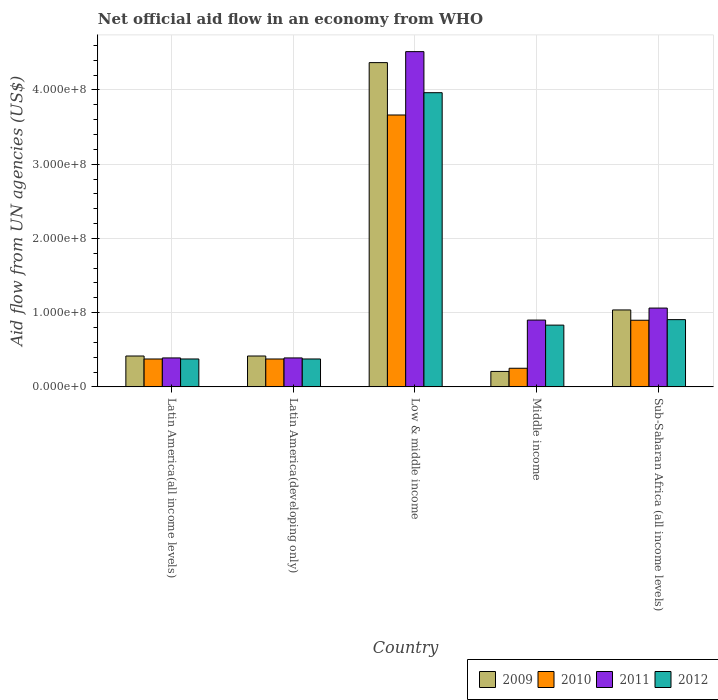How many different coloured bars are there?
Provide a short and direct response. 4. How many groups of bars are there?
Your answer should be compact. 5. Are the number of bars per tick equal to the number of legend labels?
Provide a short and direct response. Yes. What is the label of the 5th group of bars from the left?
Provide a succinct answer. Sub-Saharan Africa (all income levels). In how many cases, is the number of bars for a given country not equal to the number of legend labels?
Provide a succinct answer. 0. What is the net official aid flow in 2012 in Sub-Saharan Africa (all income levels)?
Your answer should be compact. 9.06e+07. Across all countries, what is the maximum net official aid flow in 2010?
Your answer should be very brief. 3.66e+08. Across all countries, what is the minimum net official aid flow in 2009?
Your response must be concise. 2.08e+07. In which country was the net official aid flow in 2011 minimum?
Offer a very short reply. Latin America(all income levels). What is the total net official aid flow in 2009 in the graph?
Provide a succinct answer. 6.44e+08. What is the difference between the net official aid flow in 2012 in Latin America(all income levels) and that in Sub-Saharan Africa (all income levels)?
Offer a very short reply. -5.30e+07. What is the difference between the net official aid flow in 2010 in Low & middle income and the net official aid flow in 2012 in Middle income?
Provide a short and direct response. 2.83e+08. What is the average net official aid flow in 2011 per country?
Give a very brief answer. 1.45e+08. What is the difference between the net official aid flow of/in 2012 and net official aid flow of/in 2010 in Low & middle income?
Provide a succinct answer. 3.00e+07. In how many countries, is the net official aid flow in 2010 greater than 360000000 US$?
Keep it short and to the point. 1. What is the ratio of the net official aid flow in 2012 in Low & middle income to that in Sub-Saharan Africa (all income levels)?
Your answer should be very brief. 4.38. Is the difference between the net official aid flow in 2012 in Latin America(all income levels) and Middle income greater than the difference between the net official aid flow in 2010 in Latin America(all income levels) and Middle income?
Your response must be concise. No. What is the difference between the highest and the second highest net official aid flow in 2011?
Make the answer very short. 3.45e+08. What is the difference between the highest and the lowest net official aid flow in 2011?
Your response must be concise. 4.13e+08. Is the sum of the net official aid flow in 2009 in Low & middle income and Middle income greater than the maximum net official aid flow in 2011 across all countries?
Keep it short and to the point. Yes. What does the 2nd bar from the left in Sub-Saharan Africa (all income levels) represents?
Offer a terse response. 2010. Are all the bars in the graph horizontal?
Your response must be concise. No. How many countries are there in the graph?
Offer a very short reply. 5. Are the values on the major ticks of Y-axis written in scientific E-notation?
Provide a succinct answer. Yes. Does the graph contain any zero values?
Keep it short and to the point. No. Where does the legend appear in the graph?
Your answer should be very brief. Bottom right. How many legend labels are there?
Your response must be concise. 4. What is the title of the graph?
Provide a short and direct response. Net official aid flow in an economy from WHO. Does "1961" appear as one of the legend labels in the graph?
Your answer should be compact. No. What is the label or title of the X-axis?
Provide a succinct answer. Country. What is the label or title of the Y-axis?
Your response must be concise. Aid flow from UN agencies (US$). What is the Aid flow from UN agencies (US$) of 2009 in Latin America(all income levels)?
Your answer should be very brief. 4.16e+07. What is the Aid flow from UN agencies (US$) in 2010 in Latin America(all income levels)?
Provide a succinct answer. 3.76e+07. What is the Aid flow from UN agencies (US$) of 2011 in Latin America(all income levels)?
Provide a short and direct response. 3.90e+07. What is the Aid flow from UN agencies (US$) of 2012 in Latin America(all income levels)?
Give a very brief answer. 3.76e+07. What is the Aid flow from UN agencies (US$) in 2009 in Latin America(developing only)?
Provide a short and direct response. 4.16e+07. What is the Aid flow from UN agencies (US$) of 2010 in Latin America(developing only)?
Ensure brevity in your answer.  3.76e+07. What is the Aid flow from UN agencies (US$) of 2011 in Latin America(developing only)?
Give a very brief answer. 3.90e+07. What is the Aid flow from UN agencies (US$) in 2012 in Latin America(developing only)?
Provide a succinct answer. 3.76e+07. What is the Aid flow from UN agencies (US$) of 2009 in Low & middle income?
Offer a very short reply. 4.37e+08. What is the Aid flow from UN agencies (US$) of 2010 in Low & middle income?
Offer a terse response. 3.66e+08. What is the Aid flow from UN agencies (US$) of 2011 in Low & middle income?
Your answer should be very brief. 4.52e+08. What is the Aid flow from UN agencies (US$) in 2012 in Low & middle income?
Your answer should be compact. 3.96e+08. What is the Aid flow from UN agencies (US$) of 2009 in Middle income?
Make the answer very short. 2.08e+07. What is the Aid flow from UN agencies (US$) in 2010 in Middle income?
Your answer should be very brief. 2.51e+07. What is the Aid flow from UN agencies (US$) in 2011 in Middle income?
Provide a succinct answer. 9.00e+07. What is the Aid flow from UN agencies (US$) in 2012 in Middle income?
Give a very brief answer. 8.32e+07. What is the Aid flow from UN agencies (US$) in 2009 in Sub-Saharan Africa (all income levels)?
Provide a short and direct response. 1.04e+08. What is the Aid flow from UN agencies (US$) of 2010 in Sub-Saharan Africa (all income levels)?
Make the answer very short. 8.98e+07. What is the Aid flow from UN agencies (US$) of 2011 in Sub-Saharan Africa (all income levels)?
Your answer should be very brief. 1.06e+08. What is the Aid flow from UN agencies (US$) of 2012 in Sub-Saharan Africa (all income levels)?
Offer a very short reply. 9.06e+07. Across all countries, what is the maximum Aid flow from UN agencies (US$) in 2009?
Ensure brevity in your answer.  4.37e+08. Across all countries, what is the maximum Aid flow from UN agencies (US$) in 2010?
Your answer should be very brief. 3.66e+08. Across all countries, what is the maximum Aid flow from UN agencies (US$) of 2011?
Provide a succinct answer. 4.52e+08. Across all countries, what is the maximum Aid flow from UN agencies (US$) in 2012?
Your answer should be compact. 3.96e+08. Across all countries, what is the minimum Aid flow from UN agencies (US$) in 2009?
Ensure brevity in your answer.  2.08e+07. Across all countries, what is the minimum Aid flow from UN agencies (US$) of 2010?
Your answer should be very brief. 2.51e+07. Across all countries, what is the minimum Aid flow from UN agencies (US$) in 2011?
Provide a succinct answer. 3.90e+07. Across all countries, what is the minimum Aid flow from UN agencies (US$) in 2012?
Keep it short and to the point. 3.76e+07. What is the total Aid flow from UN agencies (US$) of 2009 in the graph?
Keep it short and to the point. 6.44e+08. What is the total Aid flow from UN agencies (US$) in 2010 in the graph?
Your answer should be very brief. 5.56e+08. What is the total Aid flow from UN agencies (US$) in 2011 in the graph?
Make the answer very short. 7.26e+08. What is the total Aid flow from UN agencies (US$) of 2012 in the graph?
Offer a very short reply. 6.45e+08. What is the difference between the Aid flow from UN agencies (US$) of 2010 in Latin America(all income levels) and that in Latin America(developing only)?
Provide a short and direct response. 0. What is the difference between the Aid flow from UN agencies (US$) of 2009 in Latin America(all income levels) and that in Low & middle income?
Provide a succinct answer. -3.95e+08. What is the difference between the Aid flow from UN agencies (US$) of 2010 in Latin America(all income levels) and that in Low & middle income?
Provide a succinct answer. -3.29e+08. What is the difference between the Aid flow from UN agencies (US$) of 2011 in Latin America(all income levels) and that in Low & middle income?
Your answer should be compact. -4.13e+08. What is the difference between the Aid flow from UN agencies (US$) of 2012 in Latin America(all income levels) and that in Low & middle income?
Make the answer very short. -3.59e+08. What is the difference between the Aid flow from UN agencies (US$) in 2009 in Latin America(all income levels) and that in Middle income?
Offer a very short reply. 2.08e+07. What is the difference between the Aid flow from UN agencies (US$) in 2010 in Latin America(all income levels) and that in Middle income?
Your response must be concise. 1.25e+07. What is the difference between the Aid flow from UN agencies (US$) in 2011 in Latin America(all income levels) and that in Middle income?
Your answer should be compact. -5.10e+07. What is the difference between the Aid flow from UN agencies (US$) of 2012 in Latin America(all income levels) and that in Middle income?
Keep it short and to the point. -4.56e+07. What is the difference between the Aid flow from UN agencies (US$) in 2009 in Latin America(all income levels) and that in Sub-Saharan Africa (all income levels)?
Give a very brief answer. -6.20e+07. What is the difference between the Aid flow from UN agencies (US$) of 2010 in Latin America(all income levels) and that in Sub-Saharan Africa (all income levels)?
Make the answer very short. -5.22e+07. What is the difference between the Aid flow from UN agencies (US$) in 2011 in Latin America(all income levels) and that in Sub-Saharan Africa (all income levels)?
Ensure brevity in your answer.  -6.72e+07. What is the difference between the Aid flow from UN agencies (US$) of 2012 in Latin America(all income levels) and that in Sub-Saharan Africa (all income levels)?
Provide a short and direct response. -5.30e+07. What is the difference between the Aid flow from UN agencies (US$) of 2009 in Latin America(developing only) and that in Low & middle income?
Make the answer very short. -3.95e+08. What is the difference between the Aid flow from UN agencies (US$) in 2010 in Latin America(developing only) and that in Low & middle income?
Give a very brief answer. -3.29e+08. What is the difference between the Aid flow from UN agencies (US$) in 2011 in Latin America(developing only) and that in Low & middle income?
Offer a very short reply. -4.13e+08. What is the difference between the Aid flow from UN agencies (US$) of 2012 in Latin America(developing only) and that in Low & middle income?
Ensure brevity in your answer.  -3.59e+08. What is the difference between the Aid flow from UN agencies (US$) in 2009 in Latin America(developing only) and that in Middle income?
Make the answer very short. 2.08e+07. What is the difference between the Aid flow from UN agencies (US$) of 2010 in Latin America(developing only) and that in Middle income?
Provide a succinct answer. 1.25e+07. What is the difference between the Aid flow from UN agencies (US$) of 2011 in Latin America(developing only) and that in Middle income?
Provide a short and direct response. -5.10e+07. What is the difference between the Aid flow from UN agencies (US$) in 2012 in Latin America(developing only) and that in Middle income?
Your answer should be very brief. -4.56e+07. What is the difference between the Aid flow from UN agencies (US$) of 2009 in Latin America(developing only) and that in Sub-Saharan Africa (all income levels)?
Offer a terse response. -6.20e+07. What is the difference between the Aid flow from UN agencies (US$) in 2010 in Latin America(developing only) and that in Sub-Saharan Africa (all income levels)?
Provide a short and direct response. -5.22e+07. What is the difference between the Aid flow from UN agencies (US$) in 2011 in Latin America(developing only) and that in Sub-Saharan Africa (all income levels)?
Provide a succinct answer. -6.72e+07. What is the difference between the Aid flow from UN agencies (US$) of 2012 in Latin America(developing only) and that in Sub-Saharan Africa (all income levels)?
Make the answer very short. -5.30e+07. What is the difference between the Aid flow from UN agencies (US$) in 2009 in Low & middle income and that in Middle income?
Your answer should be very brief. 4.16e+08. What is the difference between the Aid flow from UN agencies (US$) in 2010 in Low & middle income and that in Middle income?
Provide a succinct answer. 3.41e+08. What is the difference between the Aid flow from UN agencies (US$) in 2011 in Low & middle income and that in Middle income?
Provide a short and direct response. 3.62e+08. What is the difference between the Aid flow from UN agencies (US$) of 2012 in Low & middle income and that in Middle income?
Your response must be concise. 3.13e+08. What is the difference between the Aid flow from UN agencies (US$) of 2009 in Low & middle income and that in Sub-Saharan Africa (all income levels)?
Keep it short and to the point. 3.33e+08. What is the difference between the Aid flow from UN agencies (US$) in 2010 in Low & middle income and that in Sub-Saharan Africa (all income levels)?
Your answer should be compact. 2.76e+08. What is the difference between the Aid flow from UN agencies (US$) in 2011 in Low & middle income and that in Sub-Saharan Africa (all income levels)?
Offer a terse response. 3.45e+08. What is the difference between the Aid flow from UN agencies (US$) in 2012 in Low & middle income and that in Sub-Saharan Africa (all income levels)?
Provide a short and direct response. 3.06e+08. What is the difference between the Aid flow from UN agencies (US$) in 2009 in Middle income and that in Sub-Saharan Africa (all income levels)?
Your answer should be very brief. -8.28e+07. What is the difference between the Aid flow from UN agencies (US$) of 2010 in Middle income and that in Sub-Saharan Africa (all income levels)?
Your answer should be compact. -6.47e+07. What is the difference between the Aid flow from UN agencies (US$) in 2011 in Middle income and that in Sub-Saharan Africa (all income levels)?
Offer a very short reply. -1.62e+07. What is the difference between the Aid flow from UN agencies (US$) in 2012 in Middle income and that in Sub-Saharan Africa (all income levels)?
Offer a very short reply. -7.39e+06. What is the difference between the Aid flow from UN agencies (US$) in 2009 in Latin America(all income levels) and the Aid flow from UN agencies (US$) in 2010 in Latin America(developing only)?
Keep it short and to the point. 4.01e+06. What is the difference between the Aid flow from UN agencies (US$) of 2009 in Latin America(all income levels) and the Aid flow from UN agencies (US$) of 2011 in Latin America(developing only)?
Make the answer very short. 2.59e+06. What is the difference between the Aid flow from UN agencies (US$) of 2009 in Latin America(all income levels) and the Aid flow from UN agencies (US$) of 2012 in Latin America(developing only)?
Ensure brevity in your answer.  3.99e+06. What is the difference between the Aid flow from UN agencies (US$) of 2010 in Latin America(all income levels) and the Aid flow from UN agencies (US$) of 2011 in Latin America(developing only)?
Your answer should be very brief. -1.42e+06. What is the difference between the Aid flow from UN agencies (US$) of 2011 in Latin America(all income levels) and the Aid flow from UN agencies (US$) of 2012 in Latin America(developing only)?
Provide a succinct answer. 1.40e+06. What is the difference between the Aid flow from UN agencies (US$) of 2009 in Latin America(all income levels) and the Aid flow from UN agencies (US$) of 2010 in Low & middle income?
Make the answer very short. -3.25e+08. What is the difference between the Aid flow from UN agencies (US$) in 2009 in Latin America(all income levels) and the Aid flow from UN agencies (US$) in 2011 in Low & middle income?
Provide a short and direct response. -4.10e+08. What is the difference between the Aid flow from UN agencies (US$) of 2009 in Latin America(all income levels) and the Aid flow from UN agencies (US$) of 2012 in Low & middle income?
Provide a short and direct response. -3.55e+08. What is the difference between the Aid flow from UN agencies (US$) of 2010 in Latin America(all income levels) and the Aid flow from UN agencies (US$) of 2011 in Low & middle income?
Make the answer very short. -4.14e+08. What is the difference between the Aid flow from UN agencies (US$) in 2010 in Latin America(all income levels) and the Aid flow from UN agencies (US$) in 2012 in Low & middle income?
Offer a very short reply. -3.59e+08. What is the difference between the Aid flow from UN agencies (US$) of 2011 in Latin America(all income levels) and the Aid flow from UN agencies (US$) of 2012 in Low & middle income?
Make the answer very short. -3.57e+08. What is the difference between the Aid flow from UN agencies (US$) of 2009 in Latin America(all income levels) and the Aid flow from UN agencies (US$) of 2010 in Middle income?
Offer a terse response. 1.65e+07. What is the difference between the Aid flow from UN agencies (US$) of 2009 in Latin America(all income levels) and the Aid flow from UN agencies (US$) of 2011 in Middle income?
Your response must be concise. -4.84e+07. What is the difference between the Aid flow from UN agencies (US$) of 2009 in Latin America(all income levels) and the Aid flow from UN agencies (US$) of 2012 in Middle income?
Your response must be concise. -4.16e+07. What is the difference between the Aid flow from UN agencies (US$) in 2010 in Latin America(all income levels) and the Aid flow from UN agencies (US$) in 2011 in Middle income?
Provide a succinct answer. -5.24e+07. What is the difference between the Aid flow from UN agencies (US$) in 2010 in Latin America(all income levels) and the Aid flow from UN agencies (US$) in 2012 in Middle income?
Your answer should be compact. -4.56e+07. What is the difference between the Aid flow from UN agencies (US$) in 2011 in Latin America(all income levels) and the Aid flow from UN agencies (US$) in 2012 in Middle income?
Ensure brevity in your answer.  -4.42e+07. What is the difference between the Aid flow from UN agencies (US$) of 2009 in Latin America(all income levels) and the Aid flow from UN agencies (US$) of 2010 in Sub-Saharan Africa (all income levels)?
Ensure brevity in your answer.  -4.82e+07. What is the difference between the Aid flow from UN agencies (US$) in 2009 in Latin America(all income levels) and the Aid flow from UN agencies (US$) in 2011 in Sub-Saharan Africa (all income levels)?
Your response must be concise. -6.46e+07. What is the difference between the Aid flow from UN agencies (US$) of 2009 in Latin America(all income levels) and the Aid flow from UN agencies (US$) of 2012 in Sub-Saharan Africa (all income levels)?
Make the answer very short. -4.90e+07. What is the difference between the Aid flow from UN agencies (US$) in 2010 in Latin America(all income levels) and the Aid flow from UN agencies (US$) in 2011 in Sub-Saharan Africa (all income levels)?
Provide a succinct answer. -6.86e+07. What is the difference between the Aid flow from UN agencies (US$) in 2010 in Latin America(all income levels) and the Aid flow from UN agencies (US$) in 2012 in Sub-Saharan Africa (all income levels)?
Offer a very short reply. -5.30e+07. What is the difference between the Aid flow from UN agencies (US$) in 2011 in Latin America(all income levels) and the Aid flow from UN agencies (US$) in 2012 in Sub-Saharan Africa (all income levels)?
Keep it short and to the point. -5.16e+07. What is the difference between the Aid flow from UN agencies (US$) in 2009 in Latin America(developing only) and the Aid flow from UN agencies (US$) in 2010 in Low & middle income?
Keep it short and to the point. -3.25e+08. What is the difference between the Aid flow from UN agencies (US$) of 2009 in Latin America(developing only) and the Aid flow from UN agencies (US$) of 2011 in Low & middle income?
Give a very brief answer. -4.10e+08. What is the difference between the Aid flow from UN agencies (US$) of 2009 in Latin America(developing only) and the Aid flow from UN agencies (US$) of 2012 in Low & middle income?
Your response must be concise. -3.55e+08. What is the difference between the Aid flow from UN agencies (US$) of 2010 in Latin America(developing only) and the Aid flow from UN agencies (US$) of 2011 in Low & middle income?
Your answer should be compact. -4.14e+08. What is the difference between the Aid flow from UN agencies (US$) in 2010 in Latin America(developing only) and the Aid flow from UN agencies (US$) in 2012 in Low & middle income?
Your response must be concise. -3.59e+08. What is the difference between the Aid flow from UN agencies (US$) of 2011 in Latin America(developing only) and the Aid flow from UN agencies (US$) of 2012 in Low & middle income?
Your answer should be compact. -3.57e+08. What is the difference between the Aid flow from UN agencies (US$) of 2009 in Latin America(developing only) and the Aid flow from UN agencies (US$) of 2010 in Middle income?
Give a very brief answer. 1.65e+07. What is the difference between the Aid flow from UN agencies (US$) of 2009 in Latin America(developing only) and the Aid flow from UN agencies (US$) of 2011 in Middle income?
Provide a succinct answer. -4.84e+07. What is the difference between the Aid flow from UN agencies (US$) in 2009 in Latin America(developing only) and the Aid flow from UN agencies (US$) in 2012 in Middle income?
Give a very brief answer. -4.16e+07. What is the difference between the Aid flow from UN agencies (US$) in 2010 in Latin America(developing only) and the Aid flow from UN agencies (US$) in 2011 in Middle income?
Your response must be concise. -5.24e+07. What is the difference between the Aid flow from UN agencies (US$) in 2010 in Latin America(developing only) and the Aid flow from UN agencies (US$) in 2012 in Middle income?
Provide a succinct answer. -4.56e+07. What is the difference between the Aid flow from UN agencies (US$) of 2011 in Latin America(developing only) and the Aid flow from UN agencies (US$) of 2012 in Middle income?
Make the answer very short. -4.42e+07. What is the difference between the Aid flow from UN agencies (US$) of 2009 in Latin America(developing only) and the Aid flow from UN agencies (US$) of 2010 in Sub-Saharan Africa (all income levels)?
Keep it short and to the point. -4.82e+07. What is the difference between the Aid flow from UN agencies (US$) in 2009 in Latin America(developing only) and the Aid flow from UN agencies (US$) in 2011 in Sub-Saharan Africa (all income levels)?
Keep it short and to the point. -6.46e+07. What is the difference between the Aid flow from UN agencies (US$) in 2009 in Latin America(developing only) and the Aid flow from UN agencies (US$) in 2012 in Sub-Saharan Africa (all income levels)?
Provide a short and direct response. -4.90e+07. What is the difference between the Aid flow from UN agencies (US$) in 2010 in Latin America(developing only) and the Aid flow from UN agencies (US$) in 2011 in Sub-Saharan Africa (all income levels)?
Your answer should be very brief. -6.86e+07. What is the difference between the Aid flow from UN agencies (US$) in 2010 in Latin America(developing only) and the Aid flow from UN agencies (US$) in 2012 in Sub-Saharan Africa (all income levels)?
Make the answer very short. -5.30e+07. What is the difference between the Aid flow from UN agencies (US$) in 2011 in Latin America(developing only) and the Aid flow from UN agencies (US$) in 2012 in Sub-Saharan Africa (all income levels)?
Give a very brief answer. -5.16e+07. What is the difference between the Aid flow from UN agencies (US$) in 2009 in Low & middle income and the Aid flow from UN agencies (US$) in 2010 in Middle income?
Make the answer very short. 4.12e+08. What is the difference between the Aid flow from UN agencies (US$) in 2009 in Low & middle income and the Aid flow from UN agencies (US$) in 2011 in Middle income?
Ensure brevity in your answer.  3.47e+08. What is the difference between the Aid flow from UN agencies (US$) of 2009 in Low & middle income and the Aid flow from UN agencies (US$) of 2012 in Middle income?
Give a very brief answer. 3.54e+08. What is the difference between the Aid flow from UN agencies (US$) of 2010 in Low & middle income and the Aid flow from UN agencies (US$) of 2011 in Middle income?
Your answer should be compact. 2.76e+08. What is the difference between the Aid flow from UN agencies (US$) in 2010 in Low & middle income and the Aid flow from UN agencies (US$) in 2012 in Middle income?
Your answer should be compact. 2.83e+08. What is the difference between the Aid flow from UN agencies (US$) in 2011 in Low & middle income and the Aid flow from UN agencies (US$) in 2012 in Middle income?
Offer a terse response. 3.68e+08. What is the difference between the Aid flow from UN agencies (US$) of 2009 in Low & middle income and the Aid flow from UN agencies (US$) of 2010 in Sub-Saharan Africa (all income levels)?
Offer a very short reply. 3.47e+08. What is the difference between the Aid flow from UN agencies (US$) of 2009 in Low & middle income and the Aid flow from UN agencies (US$) of 2011 in Sub-Saharan Africa (all income levels)?
Offer a terse response. 3.31e+08. What is the difference between the Aid flow from UN agencies (US$) in 2009 in Low & middle income and the Aid flow from UN agencies (US$) in 2012 in Sub-Saharan Africa (all income levels)?
Your answer should be very brief. 3.46e+08. What is the difference between the Aid flow from UN agencies (US$) of 2010 in Low & middle income and the Aid flow from UN agencies (US$) of 2011 in Sub-Saharan Africa (all income levels)?
Ensure brevity in your answer.  2.60e+08. What is the difference between the Aid flow from UN agencies (US$) of 2010 in Low & middle income and the Aid flow from UN agencies (US$) of 2012 in Sub-Saharan Africa (all income levels)?
Offer a terse response. 2.76e+08. What is the difference between the Aid flow from UN agencies (US$) in 2011 in Low & middle income and the Aid flow from UN agencies (US$) in 2012 in Sub-Saharan Africa (all income levels)?
Your response must be concise. 3.61e+08. What is the difference between the Aid flow from UN agencies (US$) in 2009 in Middle income and the Aid flow from UN agencies (US$) in 2010 in Sub-Saharan Africa (all income levels)?
Ensure brevity in your answer.  -6.90e+07. What is the difference between the Aid flow from UN agencies (US$) of 2009 in Middle income and the Aid flow from UN agencies (US$) of 2011 in Sub-Saharan Africa (all income levels)?
Ensure brevity in your answer.  -8.54e+07. What is the difference between the Aid flow from UN agencies (US$) of 2009 in Middle income and the Aid flow from UN agencies (US$) of 2012 in Sub-Saharan Africa (all income levels)?
Offer a terse response. -6.98e+07. What is the difference between the Aid flow from UN agencies (US$) in 2010 in Middle income and the Aid flow from UN agencies (US$) in 2011 in Sub-Saharan Africa (all income levels)?
Your answer should be very brief. -8.11e+07. What is the difference between the Aid flow from UN agencies (US$) in 2010 in Middle income and the Aid flow from UN agencies (US$) in 2012 in Sub-Saharan Africa (all income levels)?
Offer a very short reply. -6.55e+07. What is the difference between the Aid flow from UN agencies (US$) in 2011 in Middle income and the Aid flow from UN agencies (US$) in 2012 in Sub-Saharan Africa (all income levels)?
Provide a succinct answer. -5.90e+05. What is the average Aid flow from UN agencies (US$) of 2009 per country?
Your answer should be compact. 1.29e+08. What is the average Aid flow from UN agencies (US$) of 2010 per country?
Make the answer very short. 1.11e+08. What is the average Aid flow from UN agencies (US$) of 2011 per country?
Give a very brief answer. 1.45e+08. What is the average Aid flow from UN agencies (US$) of 2012 per country?
Ensure brevity in your answer.  1.29e+08. What is the difference between the Aid flow from UN agencies (US$) in 2009 and Aid flow from UN agencies (US$) in 2010 in Latin America(all income levels)?
Give a very brief answer. 4.01e+06. What is the difference between the Aid flow from UN agencies (US$) of 2009 and Aid flow from UN agencies (US$) of 2011 in Latin America(all income levels)?
Provide a succinct answer. 2.59e+06. What is the difference between the Aid flow from UN agencies (US$) in 2009 and Aid flow from UN agencies (US$) in 2012 in Latin America(all income levels)?
Provide a succinct answer. 3.99e+06. What is the difference between the Aid flow from UN agencies (US$) in 2010 and Aid flow from UN agencies (US$) in 2011 in Latin America(all income levels)?
Your answer should be very brief. -1.42e+06. What is the difference between the Aid flow from UN agencies (US$) in 2011 and Aid flow from UN agencies (US$) in 2012 in Latin America(all income levels)?
Your response must be concise. 1.40e+06. What is the difference between the Aid flow from UN agencies (US$) of 2009 and Aid flow from UN agencies (US$) of 2010 in Latin America(developing only)?
Give a very brief answer. 4.01e+06. What is the difference between the Aid flow from UN agencies (US$) in 2009 and Aid flow from UN agencies (US$) in 2011 in Latin America(developing only)?
Your answer should be very brief. 2.59e+06. What is the difference between the Aid flow from UN agencies (US$) of 2009 and Aid flow from UN agencies (US$) of 2012 in Latin America(developing only)?
Keep it short and to the point. 3.99e+06. What is the difference between the Aid flow from UN agencies (US$) of 2010 and Aid flow from UN agencies (US$) of 2011 in Latin America(developing only)?
Your answer should be very brief. -1.42e+06. What is the difference between the Aid flow from UN agencies (US$) in 2010 and Aid flow from UN agencies (US$) in 2012 in Latin America(developing only)?
Keep it short and to the point. -2.00e+04. What is the difference between the Aid flow from UN agencies (US$) in 2011 and Aid flow from UN agencies (US$) in 2012 in Latin America(developing only)?
Provide a succinct answer. 1.40e+06. What is the difference between the Aid flow from UN agencies (US$) in 2009 and Aid flow from UN agencies (US$) in 2010 in Low & middle income?
Make the answer very short. 7.06e+07. What is the difference between the Aid flow from UN agencies (US$) in 2009 and Aid flow from UN agencies (US$) in 2011 in Low & middle income?
Your response must be concise. -1.48e+07. What is the difference between the Aid flow from UN agencies (US$) in 2009 and Aid flow from UN agencies (US$) in 2012 in Low & middle income?
Make the answer very short. 4.05e+07. What is the difference between the Aid flow from UN agencies (US$) in 2010 and Aid flow from UN agencies (US$) in 2011 in Low & middle income?
Offer a terse response. -8.54e+07. What is the difference between the Aid flow from UN agencies (US$) in 2010 and Aid flow from UN agencies (US$) in 2012 in Low & middle income?
Your answer should be compact. -3.00e+07. What is the difference between the Aid flow from UN agencies (US$) in 2011 and Aid flow from UN agencies (US$) in 2012 in Low & middle income?
Provide a short and direct response. 5.53e+07. What is the difference between the Aid flow from UN agencies (US$) in 2009 and Aid flow from UN agencies (US$) in 2010 in Middle income?
Offer a very short reply. -4.27e+06. What is the difference between the Aid flow from UN agencies (US$) of 2009 and Aid flow from UN agencies (US$) of 2011 in Middle income?
Keep it short and to the point. -6.92e+07. What is the difference between the Aid flow from UN agencies (US$) of 2009 and Aid flow from UN agencies (US$) of 2012 in Middle income?
Make the answer very short. -6.24e+07. What is the difference between the Aid flow from UN agencies (US$) of 2010 and Aid flow from UN agencies (US$) of 2011 in Middle income?
Give a very brief answer. -6.49e+07. What is the difference between the Aid flow from UN agencies (US$) in 2010 and Aid flow from UN agencies (US$) in 2012 in Middle income?
Keep it short and to the point. -5.81e+07. What is the difference between the Aid flow from UN agencies (US$) of 2011 and Aid flow from UN agencies (US$) of 2012 in Middle income?
Offer a terse response. 6.80e+06. What is the difference between the Aid flow from UN agencies (US$) in 2009 and Aid flow from UN agencies (US$) in 2010 in Sub-Saharan Africa (all income levels)?
Provide a succinct answer. 1.39e+07. What is the difference between the Aid flow from UN agencies (US$) in 2009 and Aid flow from UN agencies (US$) in 2011 in Sub-Saharan Africa (all income levels)?
Your answer should be compact. -2.53e+06. What is the difference between the Aid flow from UN agencies (US$) of 2009 and Aid flow from UN agencies (US$) of 2012 in Sub-Saharan Africa (all income levels)?
Ensure brevity in your answer.  1.30e+07. What is the difference between the Aid flow from UN agencies (US$) of 2010 and Aid flow from UN agencies (US$) of 2011 in Sub-Saharan Africa (all income levels)?
Your answer should be compact. -1.64e+07. What is the difference between the Aid flow from UN agencies (US$) in 2010 and Aid flow from UN agencies (US$) in 2012 in Sub-Saharan Africa (all income levels)?
Provide a succinct answer. -8.10e+05. What is the difference between the Aid flow from UN agencies (US$) of 2011 and Aid flow from UN agencies (US$) of 2012 in Sub-Saharan Africa (all income levels)?
Provide a succinct answer. 1.56e+07. What is the ratio of the Aid flow from UN agencies (US$) of 2012 in Latin America(all income levels) to that in Latin America(developing only)?
Your response must be concise. 1. What is the ratio of the Aid flow from UN agencies (US$) in 2009 in Latin America(all income levels) to that in Low & middle income?
Your answer should be very brief. 0.1. What is the ratio of the Aid flow from UN agencies (US$) of 2010 in Latin America(all income levels) to that in Low & middle income?
Provide a short and direct response. 0.1. What is the ratio of the Aid flow from UN agencies (US$) in 2011 in Latin America(all income levels) to that in Low & middle income?
Ensure brevity in your answer.  0.09. What is the ratio of the Aid flow from UN agencies (US$) in 2012 in Latin America(all income levels) to that in Low & middle income?
Make the answer very short. 0.09. What is the ratio of the Aid flow from UN agencies (US$) in 2009 in Latin America(all income levels) to that in Middle income?
Your answer should be very brief. 2. What is the ratio of the Aid flow from UN agencies (US$) in 2010 in Latin America(all income levels) to that in Middle income?
Provide a short and direct response. 1.5. What is the ratio of the Aid flow from UN agencies (US$) in 2011 in Latin America(all income levels) to that in Middle income?
Provide a short and direct response. 0.43. What is the ratio of the Aid flow from UN agencies (US$) in 2012 in Latin America(all income levels) to that in Middle income?
Offer a terse response. 0.45. What is the ratio of the Aid flow from UN agencies (US$) of 2009 in Latin America(all income levels) to that in Sub-Saharan Africa (all income levels)?
Give a very brief answer. 0.4. What is the ratio of the Aid flow from UN agencies (US$) in 2010 in Latin America(all income levels) to that in Sub-Saharan Africa (all income levels)?
Give a very brief answer. 0.42. What is the ratio of the Aid flow from UN agencies (US$) in 2011 in Latin America(all income levels) to that in Sub-Saharan Africa (all income levels)?
Provide a short and direct response. 0.37. What is the ratio of the Aid flow from UN agencies (US$) in 2012 in Latin America(all income levels) to that in Sub-Saharan Africa (all income levels)?
Keep it short and to the point. 0.41. What is the ratio of the Aid flow from UN agencies (US$) in 2009 in Latin America(developing only) to that in Low & middle income?
Your answer should be very brief. 0.1. What is the ratio of the Aid flow from UN agencies (US$) of 2010 in Latin America(developing only) to that in Low & middle income?
Offer a very short reply. 0.1. What is the ratio of the Aid flow from UN agencies (US$) in 2011 in Latin America(developing only) to that in Low & middle income?
Your response must be concise. 0.09. What is the ratio of the Aid flow from UN agencies (US$) in 2012 in Latin America(developing only) to that in Low & middle income?
Offer a terse response. 0.09. What is the ratio of the Aid flow from UN agencies (US$) in 2009 in Latin America(developing only) to that in Middle income?
Provide a short and direct response. 2. What is the ratio of the Aid flow from UN agencies (US$) in 2010 in Latin America(developing only) to that in Middle income?
Keep it short and to the point. 1.5. What is the ratio of the Aid flow from UN agencies (US$) of 2011 in Latin America(developing only) to that in Middle income?
Give a very brief answer. 0.43. What is the ratio of the Aid flow from UN agencies (US$) in 2012 in Latin America(developing only) to that in Middle income?
Make the answer very short. 0.45. What is the ratio of the Aid flow from UN agencies (US$) in 2009 in Latin America(developing only) to that in Sub-Saharan Africa (all income levels)?
Offer a terse response. 0.4. What is the ratio of the Aid flow from UN agencies (US$) in 2010 in Latin America(developing only) to that in Sub-Saharan Africa (all income levels)?
Give a very brief answer. 0.42. What is the ratio of the Aid flow from UN agencies (US$) in 2011 in Latin America(developing only) to that in Sub-Saharan Africa (all income levels)?
Make the answer very short. 0.37. What is the ratio of the Aid flow from UN agencies (US$) of 2012 in Latin America(developing only) to that in Sub-Saharan Africa (all income levels)?
Keep it short and to the point. 0.41. What is the ratio of the Aid flow from UN agencies (US$) of 2009 in Low & middle income to that in Middle income?
Provide a short and direct response. 21. What is the ratio of the Aid flow from UN agencies (US$) in 2010 in Low & middle income to that in Middle income?
Make the answer very short. 14.61. What is the ratio of the Aid flow from UN agencies (US$) in 2011 in Low & middle income to that in Middle income?
Offer a very short reply. 5.02. What is the ratio of the Aid flow from UN agencies (US$) in 2012 in Low & middle income to that in Middle income?
Give a very brief answer. 4.76. What is the ratio of the Aid flow from UN agencies (US$) of 2009 in Low & middle income to that in Sub-Saharan Africa (all income levels)?
Provide a succinct answer. 4.22. What is the ratio of the Aid flow from UN agencies (US$) of 2010 in Low & middle income to that in Sub-Saharan Africa (all income levels)?
Offer a very short reply. 4.08. What is the ratio of the Aid flow from UN agencies (US$) of 2011 in Low & middle income to that in Sub-Saharan Africa (all income levels)?
Offer a very short reply. 4.25. What is the ratio of the Aid flow from UN agencies (US$) in 2012 in Low & middle income to that in Sub-Saharan Africa (all income levels)?
Your answer should be very brief. 4.38. What is the ratio of the Aid flow from UN agencies (US$) in 2009 in Middle income to that in Sub-Saharan Africa (all income levels)?
Offer a terse response. 0.2. What is the ratio of the Aid flow from UN agencies (US$) in 2010 in Middle income to that in Sub-Saharan Africa (all income levels)?
Provide a short and direct response. 0.28. What is the ratio of the Aid flow from UN agencies (US$) of 2011 in Middle income to that in Sub-Saharan Africa (all income levels)?
Your answer should be very brief. 0.85. What is the ratio of the Aid flow from UN agencies (US$) of 2012 in Middle income to that in Sub-Saharan Africa (all income levels)?
Offer a terse response. 0.92. What is the difference between the highest and the second highest Aid flow from UN agencies (US$) of 2009?
Your answer should be very brief. 3.33e+08. What is the difference between the highest and the second highest Aid flow from UN agencies (US$) in 2010?
Ensure brevity in your answer.  2.76e+08. What is the difference between the highest and the second highest Aid flow from UN agencies (US$) in 2011?
Provide a short and direct response. 3.45e+08. What is the difference between the highest and the second highest Aid flow from UN agencies (US$) in 2012?
Offer a very short reply. 3.06e+08. What is the difference between the highest and the lowest Aid flow from UN agencies (US$) of 2009?
Offer a very short reply. 4.16e+08. What is the difference between the highest and the lowest Aid flow from UN agencies (US$) of 2010?
Your answer should be compact. 3.41e+08. What is the difference between the highest and the lowest Aid flow from UN agencies (US$) in 2011?
Offer a very short reply. 4.13e+08. What is the difference between the highest and the lowest Aid flow from UN agencies (US$) of 2012?
Give a very brief answer. 3.59e+08. 